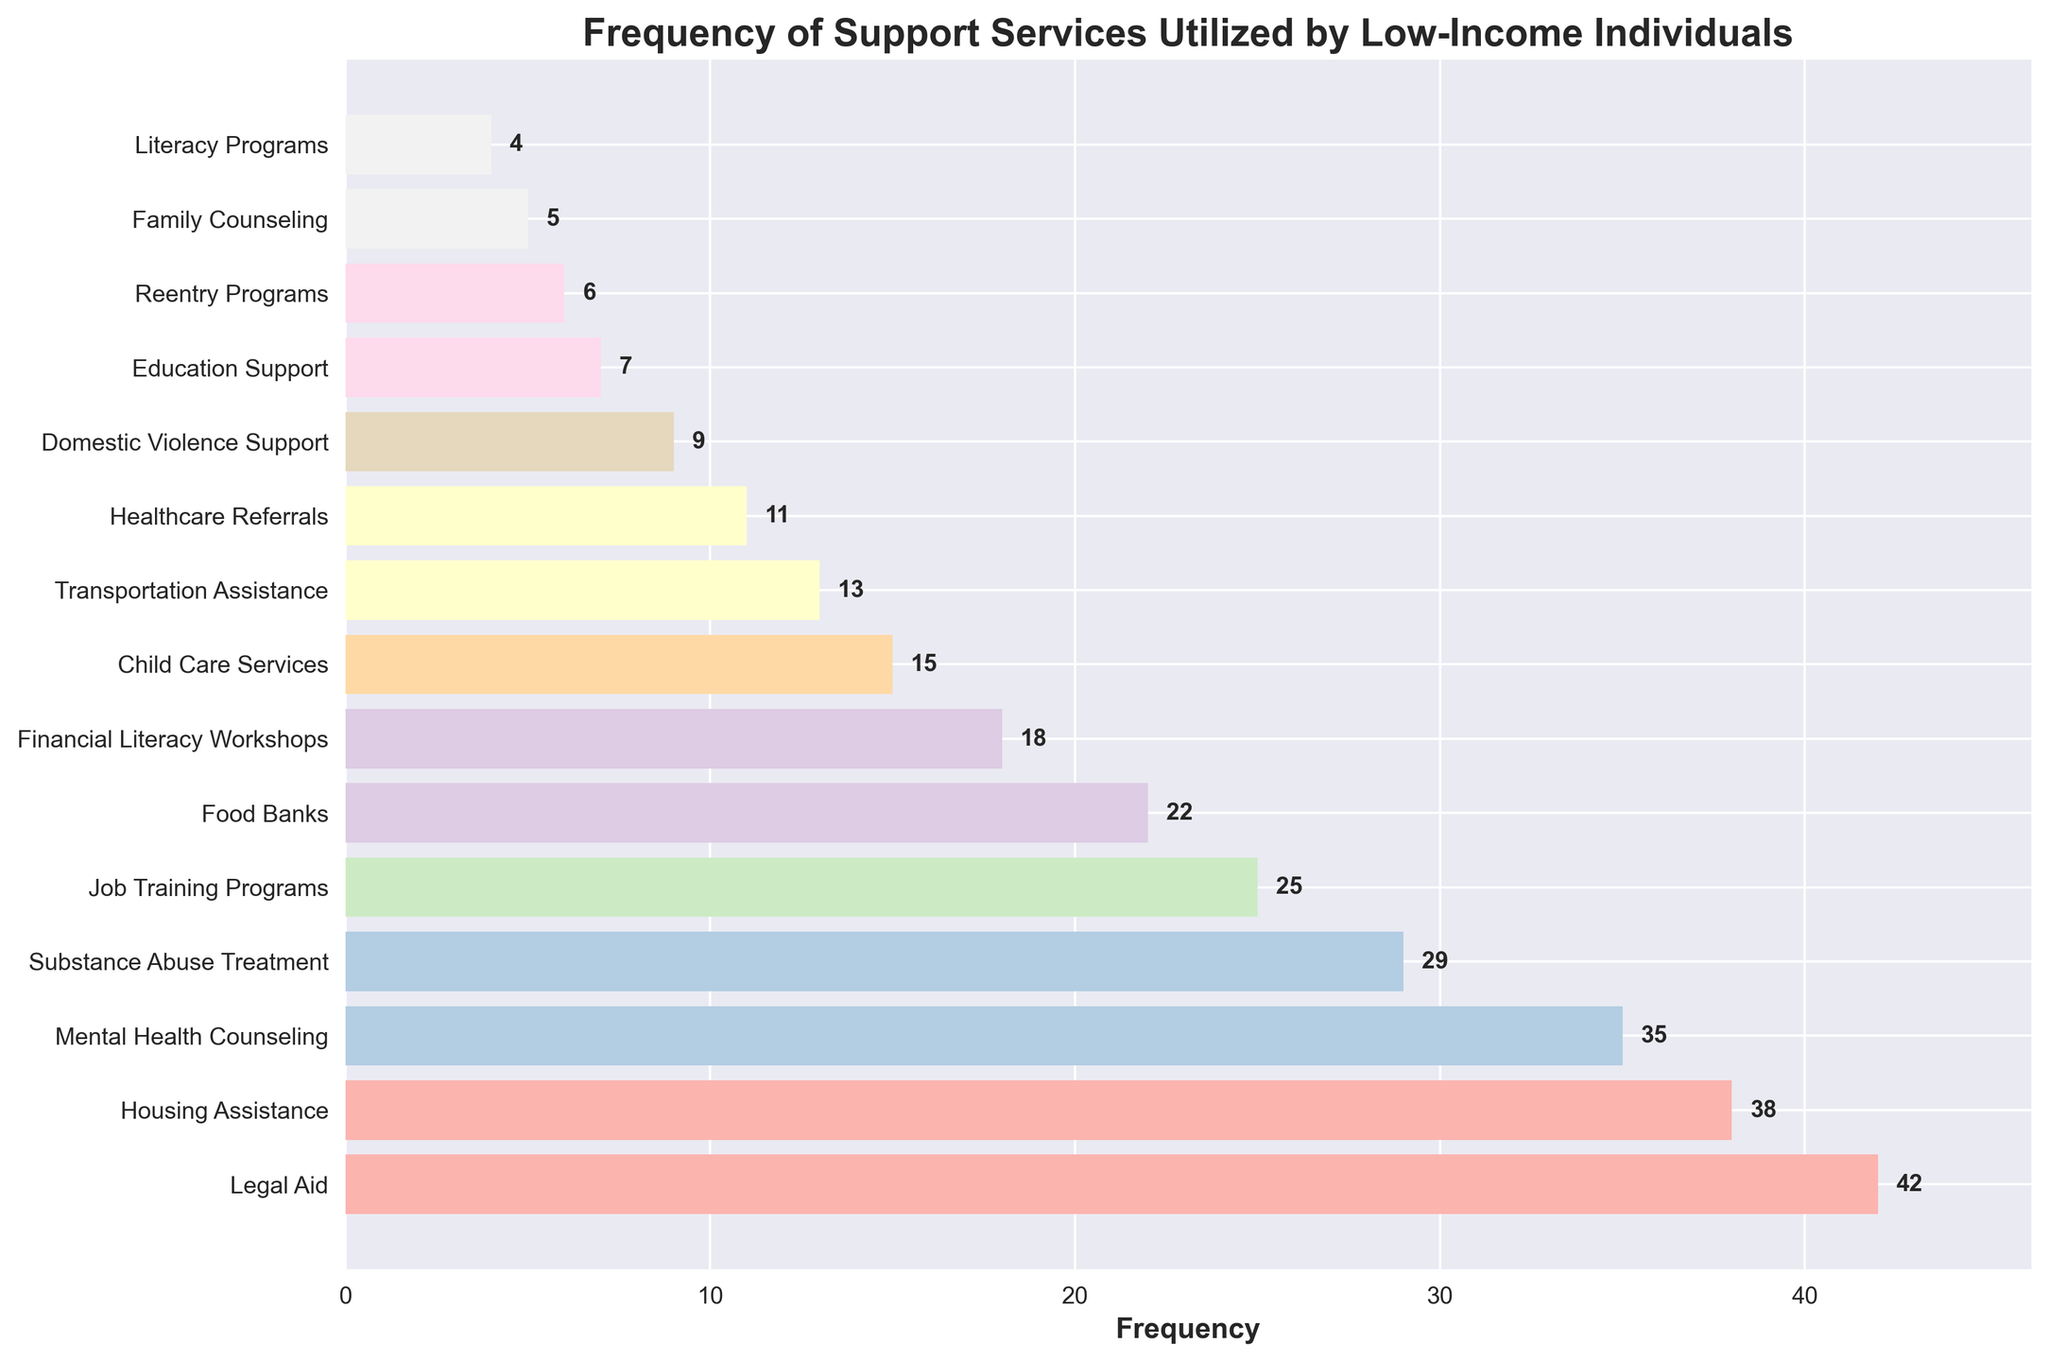Which service is utilized most frequently? The bar with the highest length represents the most frequently utilized service. In the figure, "Legal Aid" has the highest length, indicating it is the most frequently used service.
Answer: Legal Aid Which three services are least frequently utilized? The shortest three bars represent the least frequently utilized services. These are "Literacy Programs," "Family Counseling," and "Reentry Programs."
Answer: Literacy Programs, Family Counseling, Reentry Programs How many more people use Legal Aid compared to Food Banks? To find the difference, identify the frequencies for "Legal Aid" and "Food Banks" and subtract the latter from the former. Legal Aid: 42, Food Banks: 22. The difference is 42 - 22 = 20.
Answer: 20 What is the total frequency of Housing Assistance and Mental Health Counseling? To find the total frequency, identify the frequencies for both services and add them up. Housing Assistance: 38, Mental Health Counseling: 35. The total is 38 + 35 = 73.
Answer: 73 Which service is more frequently used, Transportation Assistance or Financial Literacy Workshops? Compare the lengths of the bars for "Transportation Assistance" and "Financial Literacy Workshops". Transportation Assistance: 13, Financial Literacy Workshops: 18. Financial Literacy Workshops have a higher frequency.
Answer: Financial Literacy Workshops What is the combined frequency of Job Training Programs, Food Banks, and Child Care Services? Identify the frequencies for the three services and add them. Job Training Programs: 25, Food Banks: 22, Child Care Services: 15. The total is 25 + 22 + 15 = 62.
Answer: 62 What is the average frequency of the top three most utilized services? First, identify the frequencies of the top three services: Legal Aid (42), Housing Assistance (38), and Mental Health Counseling (35). Sum them and divide by 3. The average is (42 + 38 + 35)/3 = 115/3 ≈ 38.33.
Answer: 38.33 Which two services have similar frequencies and what are they? Look for bars that are visually close in length. "Child Care Services" (15) and "Transportation Assistance" (13) have similar frequencies.
Answer: Child Care Services and Transportation Assistance What is the frequency difference between Substance Abuse Treatment and Domestic Violence Support? Identify the frequencies for both services and subtract one from the other. Substance Abuse Treatment: 29, Domestic Violence Support: 9. The difference is 29 - 9 = 20.
Answer: 20 